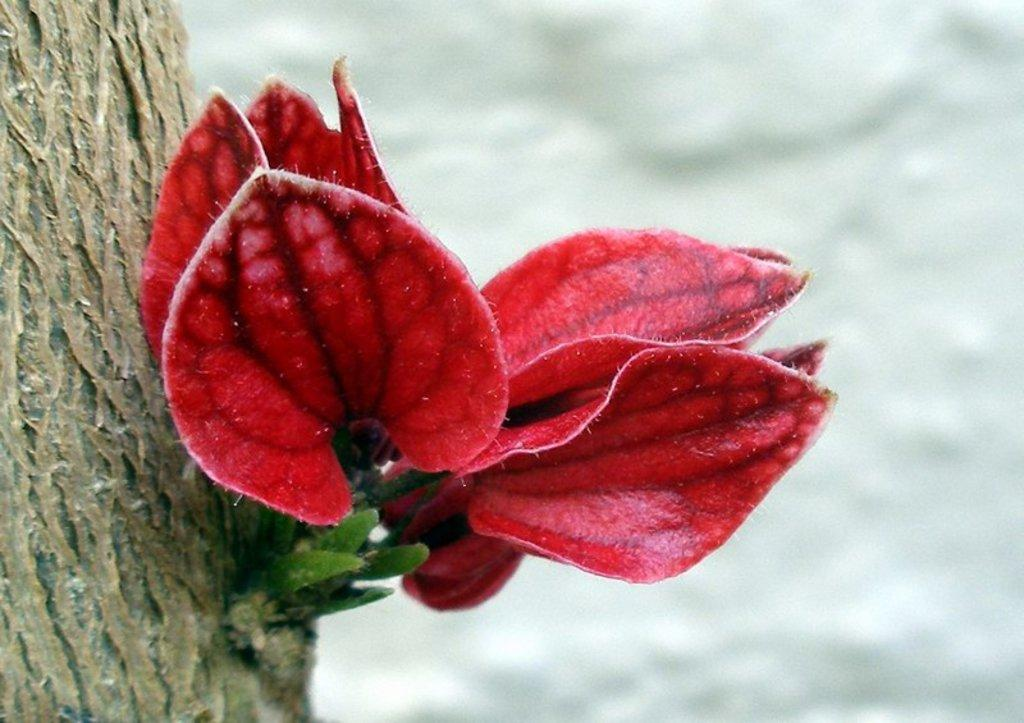What is the main subject of the image? The main subject of the image is a tree stem. What is unique about the tree's appearance? The tree has red-colored leaves. Can you describe the background of the image? The background of the image is blurred. What type of sponge can be seen hanging from the tree in the image? There is no sponge present in the image, and the tree does not have any visible objects hanging from it. 